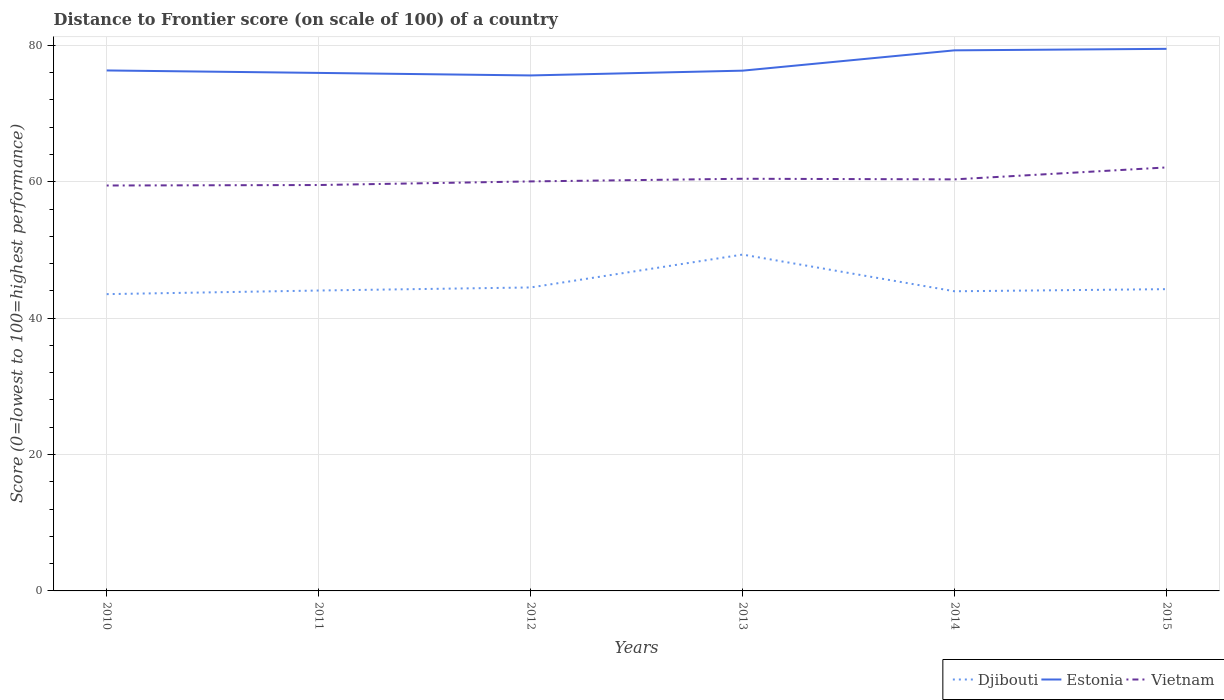How many different coloured lines are there?
Offer a terse response. 3. Is the number of lines equal to the number of legend labels?
Provide a short and direct response. Yes. Across all years, what is the maximum distance to frontier score of in Djibouti?
Your answer should be very brief. 43.52. In which year was the distance to frontier score of in Vietnam maximum?
Your answer should be compact. 2010. What is the difference between the highest and the second highest distance to frontier score of in Djibouti?
Your response must be concise. 5.8. What is the difference between the highest and the lowest distance to frontier score of in Estonia?
Provide a succinct answer. 2. Is the distance to frontier score of in Vietnam strictly greater than the distance to frontier score of in Estonia over the years?
Ensure brevity in your answer.  Yes. How many lines are there?
Make the answer very short. 3. How many years are there in the graph?
Offer a terse response. 6. Are the values on the major ticks of Y-axis written in scientific E-notation?
Provide a short and direct response. No. Where does the legend appear in the graph?
Provide a short and direct response. Bottom right. What is the title of the graph?
Your answer should be very brief. Distance to Frontier score (on scale of 100) of a country. What is the label or title of the Y-axis?
Keep it short and to the point. Score (0=lowest to 100=highest performance). What is the Score (0=lowest to 100=highest performance) of Djibouti in 2010?
Offer a very short reply. 43.52. What is the Score (0=lowest to 100=highest performance) in Estonia in 2010?
Make the answer very short. 76.32. What is the Score (0=lowest to 100=highest performance) of Vietnam in 2010?
Your response must be concise. 59.45. What is the Score (0=lowest to 100=highest performance) in Djibouti in 2011?
Provide a short and direct response. 44.05. What is the Score (0=lowest to 100=highest performance) in Estonia in 2011?
Give a very brief answer. 75.96. What is the Score (0=lowest to 100=highest performance) in Vietnam in 2011?
Give a very brief answer. 59.52. What is the Score (0=lowest to 100=highest performance) of Djibouti in 2012?
Your response must be concise. 44.5. What is the Score (0=lowest to 100=highest performance) in Estonia in 2012?
Offer a terse response. 75.59. What is the Score (0=lowest to 100=highest performance) in Vietnam in 2012?
Your response must be concise. 60.05. What is the Score (0=lowest to 100=highest performance) in Djibouti in 2013?
Give a very brief answer. 49.32. What is the Score (0=lowest to 100=highest performance) of Estonia in 2013?
Provide a short and direct response. 76.29. What is the Score (0=lowest to 100=highest performance) of Vietnam in 2013?
Provide a short and direct response. 60.44. What is the Score (0=lowest to 100=highest performance) of Djibouti in 2014?
Make the answer very short. 43.94. What is the Score (0=lowest to 100=highest performance) of Estonia in 2014?
Offer a terse response. 79.27. What is the Score (0=lowest to 100=highest performance) in Vietnam in 2014?
Your answer should be very brief. 60.35. What is the Score (0=lowest to 100=highest performance) in Djibouti in 2015?
Provide a short and direct response. 44.25. What is the Score (0=lowest to 100=highest performance) of Estonia in 2015?
Make the answer very short. 79.49. What is the Score (0=lowest to 100=highest performance) of Vietnam in 2015?
Offer a very short reply. 62.1. Across all years, what is the maximum Score (0=lowest to 100=highest performance) in Djibouti?
Provide a succinct answer. 49.32. Across all years, what is the maximum Score (0=lowest to 100=highest performance) of Estonia?
Make the answer very short. 79.49. Across all years, what is the maximum Score (0=lowest to 100=highest performance) of Vietnam?
Provide a succinct answer. 62.1. Across all years, what is the minimum Score (0=lowest to 100=highest performance) in Djibouti?
Give a very brief answer. 43.52. Across all years, what is the minimum Score (0=lowest to 100=highest performance) of Estonia?
Provide a succinct answer. 75.59. Across all years, what is the minimum Score (0=lowest to 100=highest performance) in Vietnam?
Ensure brevity in your answer.  59.45. What is the total Score (0=lowest to 100=highest performance) of Djibouti in the graph?
Ensure brevity in your answer.  269.58. What is the total Score (0=lowest to 100=highest performance) of Estonia in the graph?
Your response must be concise. 462.92. What is the total Score (0=lowest to 100=highest performance) of Vietnam in the graph?
Offer a terse response. 361.91. What is the difference between the Score (0=lowest to 100=highest performance) of Djibouti in 2010 and that in 2011?
Your answer should be compact. -0.53. What is the difference between the Score (0=lowest to 100=highest performance) of Estonia in 2010 and that in 2011?
Your response must be concise. 0.36. What is the difference between the Score (0=lowest to 100=highest performance) in Vietnam in 2010 and that in 2011?
Your answer should be compact. -0.07. What is the difference between the Score (0=lowest to 100=highest performance) of Djibouti in 2010 and that in 2012?
Offer a terse response. -0.98. What is the difference between the Score (0=lowest to 100=highest performance) in Estonia in 2010 and that in 2012?
Provide a succinct answer. 0.73. What is the difference between the Score (0=lowest to 100=highest performance) of Djibouti in 2010 and that in 2013?
Keep it short and to the point. -5.8. What is the difference between the Score (0=lowest to 100=highest performance) of Vietnam in 2010 and that in 2013?
Your answer should be very brief. -0.99. What is the difference between the Score (0=lowest to 100=highest performance) in Djibouti in 2010 and that in 2014?
Your answer should be very brief. -0.42. What is the difference between the Score (0=lowest to 100=highest performance) of Estonia in 2010 and that in 2014?
Your response must be concise. -2.95. What is the difference between the Score (0=lowest to 100=highest performance) of Vietnam in 2010 and that in 2014?
Give a very brief answer. -0.9. What is the difference between the Score (0=lowest to 100=highest performance) in Djibouti in 2010 and that in 2015?
Ensure brevity in your answer.  -0.73. What is the difference between the Score (0=lowest to 100=highest performance) of Estonia in 2010 and that in 2015?
Provide a succinct answer. -3.17. What is the difference between the Score (0=lowest to 100=highest performance) of Vietnam in 2010 and that in 2015?
Keep it short and to the point. -2.65. What is the difference between the Score (0=lowest to 100=highest performance) in Djibouti in 2011 and that in 2012?
Keep it short and to the point. -0.45. What is the difference between the Score (0=lowest to 100=highest performance) in Estonia in 2011 and that in 2012?
Keep it short and to the point. 0.37. What is the difference between the Score (0=lowest to 100=highest performance) in Vietnam in 2011 and that in 2012?
Give a very brief answer. -0.53. What is the difference between the Score (0=lowest to 100=highest performance) of Djibouti in 2011 and that in 2013?
Your response must be concise. -5.27. What is the difference between the Score (0=lowest to 100=highest performance) of Estonia in 2011 and that in 2013?
Your answer should be compact. -0.33. What is the difference between the Score (0=lowest to 100=highest performance) of Vietnam in 2011 and that in 2013?
Provide a short and direct response. -0.92. What is the difference between the Score (0=lowest to 100=highest performance) of Djibouti in 2011 and that in 2014?
Keep it short and to the point. 0.11. What is the difference between the Score (0=lowest to 100=highest performance) in Estonia in 2011 and that in 2014?
Your answer should be compact. -3.31. What is the difference between the Score (0=lowest to 100=highest performance) in Vietnam in 2011 and that in 2014?
Give a very brief answer. -0.83. What is the difference between the Score (0=lowest to 100=highest performance) of Estonia in 2011 and that in 2015?
Provide a succinct answer. -3.53. What is the difference between the Score (0=lowest to 100=highest performance) in Vietnam in 2011 and that in 2015?
Give a very brief answer. -2.58. What is the difference between the Score (0=lowest to 100=highest performance) of Djibouti in 2012 and that in 2013?
Keep it short and to the point. -4.82. What is the difference between the Score (0=lowest to 100=highest performance) of Vietnam in 2012 and that in 2013?
Give a very brief answer. -0.39. What is the difference between the Score (0=lowest to 100=highest performance) in Djibouti in 2012 and that in 2014?
Give a very brief answer. 0.56. What is the difference between the Score (0=lowest to 100=highest performance) in Estonia in 2012 and that in 2014?
Ensure brevity in your answer.  -3.68. What is the difference between the Score (0=lowest to 100=highest performance) in Vietnam in 2012 and that in 2015?
Give a very brief answer. -2.05. What is the difference between the Score (0=lowest to 100=highest performance) of Djibouti in 2013 and that in 2014?
Give a very brief answer. 5.38. What is the difference between the Score (0=lowest to 100=highest performance) in Estonia in 2013 and that in 2014?
Your answer should be compact. -2.98. What is the difference between the Score (0=lowest to 100=highest performance) of Vietnam in 2013 and that in 2014?
Keep it short and to the point. 0.09. What is the difference between the Score (0=lowest to 100=highest performance) in Djibouti in 2013 and that in 2015?
Your answer should be compact. 5.07. What is the difference between the Score (0=lowest to 100=highest performance) of Vietnam in 2013 and that in 2015?
Your answer should be compact. -1.66. What is the difference between the Score (0=lowest to 100=highest performance) of Djibouti in 2014 and that in 2015?
Your answer should be very brief. -0.31. What is the difference between the Score (0=lowest to 100=highest performance) of Estonia in 2014 and that in 2015?
Give a very brief answer. -0.22. What is the difference between the Score (0=lowest to 100=highest performance) of Vietnam in 2014 and that in 2015?
Offer a terse response. -1.75. What is the difference between the Score (0=lowest to 100=highest performance) of Djibouti in 2010 and the Score (0=lowest to 100=highest performance) of Estonia in 2011?
Your answer should be compact. -32.44. What is the difference between the Score (0=lowest to 100=highest performance) of Djibouti in 2010 and the Score (0=lowest to 100=highest performance) of Vietnam in 2011?
Your response must be concise. -16. What is the difference between the Score (0=lowest to 100=highest performance) in Djibouti in 2010 and the Score (0=lowest to 100=highest performance) in Estonia in 2012?
Provide a short and direct response. -32.07. What is the difference between the Score (0=lowest to 100=highest performance) of Djibouti in 2010 and the Score (0=lowest to 100=highest performance) of Vietnam in 2012?
Provide a short and direct response. -16.53. What is the difference between the Score (0=lowest to 100=highest performance) in Estonia in 2010 and the Score (0=lowest to 100=highest performance) in Vietnam in 2012?
Ensure brevity in your answer.  16.27. What is the difference between the Score (0=lowest to 100=highest performance) of Djibouti in 2010 and the Score (0=lowest to 100=highest performance) of Estonia in 2013?
Your answer should be compact. -32.77. What is the difference between the Score (0=lowest to 100=highest performance) of Djibouti in 2010 and the Score (0=lowest to 100=highest performance) of Vietnam in 2013?
Your answer should be compact. -16.92. What is the difference between the Score (0=lowest to 100=highest performance) in Estonia in 2010 and the Score (0=lowest to 100=highest performance) in Vietnam in 2013?
Keep it short and to the point. 15.88. What is the difference between the Score (0=lowest to 100=highest performance) of Djibouti in 2010 and the Score (0=lowest to 100=highest performance) of Estonia in 2014?
Offer a terse response. -35.75. What is the difference between the Score (0=lowest to 100=highest performance) of Djibouti in 2010 and the Score (0=lowest to 100=highest performance) of Vietnam in 2014?
Make the answer very short. -16.83. What is the difference between the Score (0=lowest to 100=highest performance) of Estonia in 2010 and the Score (0=lowest to 100=highest performance) of Vietnam in 2014?
Offer a terse response. 15.97. What is the difference between the Score (0=lowest to 100=highest performance) in Djibouti in 2010 and the Score (0=lowest to 100=highest performance) in Estonia in 2015?
Give a very brief answer. -35.97. What is the difference between the Score (0=lowest to 100=highest performance) in Djibouti in 2010 and the Score (0=lowest to 100=highest performance) in Vietnam in 2015?
Your answer should be very brief. -18.58. What is the difference between the Score (0=lowest to 100=highest performance) in Estonia in 2010 and the Score (0=lowest to 100=highest performance) in Vietnam in 2015?
Provide a succinct answer. 14.22. What is the difference between the Score (0=lowest to 100=highest performance) in Djibouti in 2011 and the Score (0=lowest to 100=highest performance) in Estonia in 2012?
Make the answer very short. -31.54. What is the difference between the Score (0=lowest to 100=highest performance) of Estonia in 2011 and the Score (0=lowest to 100=highest performance) of Vietnam in 2012?
Make the answer very short. 15.91. What is the difference between the Score (0=lowest to 100=highest performance) in Djibouti in 2011 and the Score (0=lowest to 100=highest performance) in Estonia in 2013?
Your response must be concise. -32.24. What is the difference between the Score (0=lowest to 100=highest performance) in Djibouti in 2011 and the Score (0=lowest to 100=highest performance) in Vietnam in 2013?
Make the answer very short. -16.39. What is the difference between the Score (0=lowest to 100=highest performance) in Estonia in 2011 and the Score (0=lowest to 100=highest performance) in Vietnam in 2013?
Offer a terse response. 15.52. What is the difference between the Score (0=lowest to 100=highest performance) in Djibouti in 2011 and the Score (0=lowest to 100=highest performance) in Estonia in 2014?
Provide a succinct answer. -35.22. What is the difference between the Score (0=lowest to 100=highest performance) of Djibouti in 2011 and the Score (0=lowest to 100=highest performance) of Vietnam in 2014?
Offer a very short reply. -16.3. What is the difference between the Score (0=lowest to 100=highest performance) of Estonia in 2011 and the Score (0=lowest to 100=highest performance) of Vietnam in 2014?
Your response must be concise. 15.61. What is the difference between the Score (0=lowest to 100=highest performance) in Djibouti in 2011 and the Score (0=lowest to 100=highest performance) in Estonia in 2015?
Make the answer very short. -35.44. What is the difference between the Score (0=lowest to 100=highest performance) of Djibouti in 2011 and the Score (0=lowest to 100=highest performance) of Vietnam in 2015?
Provide a succinct answer. -18.05. What is the difference between the Score (0=lowest to 100=highest performance) in Estonia in 2011 and the Score (0=lowest to 100=highest performance) in Vietnam in 2015?
Make the answer very short. 13.86. What is the difference between the Score (0=lowest to 100=highest performance) of Djibouti in 2012 and the Score (0=lowest to 100=highest performance) of Estonia in 2013?
Make the answer very short. -31.79. What is the difference between the Score (0=lowest to 100=highest performance) of Djibouti in 2012 and the Score (0=lowest to 100=highest performance) of Vietnam in 2013?
Your answer should be compact. -15.94. What is the difference between the Score (0=lowest to 100=highest performance) in Estonia in 2012 and the Score (0=lowest to 100=highest performance) in Vietnam in 2013?
Your answer should be compact. 15.15. What is the difference between the Score (0=lowest to 100=highest performance) in Djibouti in 2012 and the Score (0=lowest to 100=highest performance) in Estonia in 2014?
Offer a very short reply. -34.77. What is the difference between the Score (0=lowest to 100=highest performance) of Djibouti in 2012 and the Score (0=lowest to 100=highest performance) of Vietnam in 2014?
Offer a terse response. -15.85. What is the difference between the Score (0=lowest to 100=highest performance) in Estonia in 2012 and the Score (0=lowest to 100=highest performance) in Vietnam in 2014?
Provide a succinct answer. 15.24. What is the difference between the Score (0=lowest to 100=highest performance) of Djibouti in 2012 and the Score (0=lowest to 100=highest performance) of Estonia in 2015?
Offer a very short reply. -34.99. What is the difference between the Score (0=lowest to 100=highest performance) of Djibouti in 2012 and the Score (0=lowest to 100=highest performance) of Vietnam in 2015?
Offer a very short reply. -17.6. What is the difference between the Score (0=lowest to 100=highest performance) in Estonia in 2012 and the Score (0=lowest to 100=highest performance) in Vietnam in 2015?
Make the answer very short. 13.49. What is the difference between the Score (0=lowest to 100=highest performance) in Djibouti in 2013 and the Score (0=lowest to 100=highest performance) in Estonia in 2014?
Offer a very short reply. -29.95. What is the difference between the Score (0=lowest to 100=highest performance) in Djibouti in 2013 and the Score (0=lowest to 100=highest performance) in Vietnam in 2014?
Offer a terse response. -11.03. What is the difference between the Score (0=lowest to 100=highest performance) of Estonia in 2013 and the Score (0=lowest to 100=highest performance) of Vietnam in 2014?
Keep it short and to the point. 15.94. What is the difference between the Score (0=lowest to 100=highest performance) of Djibouti in 2013 and the Score (0=lowest to 100=highest performance) of Estonia in 2015?
Give a very brief answer. -30.17. What is the difference between the Score (0=lowest to 100=highest performance) of Djibouti in 2013 and the Score (0=lowest to 100=highest performance) of Vietnam in 2015?
Ensure brevity in your answer.  -12.78. What is the difference between the Score (0=lowest to 100=highest performance) in Estonia in 2013 and the Score (0=lowest to 100=highest performance) in Vietnam in 2015?
Give a very brief answer. 14.19. What is the difference between the Score (0=lowest to 100=highest performance) in Djibouti in 2014 and the Score (0=lowest to 100=highest performance) in Estonia in 2015?
Offer a very short reply. -35.55. What is the difference between the Score (0=lowest to 100=highest performance) of Djibouti in 2014 and the Score (0=lowest to 100=highest performance) of Vietnam in 2015?
Your answer should be very brief. -18.16. What is the difference between the Score (0=lowest to 100=highest performance) in Estonia in 2014 and the Score (0=lowest to 100=highest performance) in Vietnam in 2015?
Make the answer very short. 17.17. What is the average Score (0=lowest to 100=highest performance) in Djibouti per year?
Your answer should be very brief. 44.93. What is the average Score (0=lowest to 100=highest performance) in Estonia per year?
Give a very brief answer. 77.15. What is the average Score (0=lowest to 100=highest performance) of Vietnam per year?
Your answer should be compact. 60.32. In the year 2010, what is the difference between the Score (0=lowest to 100=highest performance) of Djibouti and Score (0=lowest to 100=highest performance) of Estonia?
Make the answer very short. -32.8. In the year 2010, what is the difference between the Score (0=lowest to 100=highest performance) in Djibouti and Score (0=lowest to 100=highest performance) in Vietnam?
Your answer should be very brief. -15.93. In the year 2010, what is the difference between the Score (0=lowest to 100=highest performance) in Estonia and Score (0=lowest to 100=highest performance) in Vietnam?
Offer a very short reply. 16.87. In the year 2011, what is the difference between the Score (0=lowest to 100=highest performance) in Djibouti and Score (0=lowest to 100=highest performance) in Estonia?
Offer a very short reply. -31.91. In the year 2011, what is the difference between the Score (0=lowest to 100=highest performance) of Djibouti and Score (0=lowest to 100=highest performance) of Vietnam?
Offer a very short reply. -15.47. In the year 2011, what is the difference between the Score (0=lowest to 100=highest performance) of Estonia and Score (0=lowest to 100=highest performance) of Vietnam?
Give a very brief answer. 16.44. In the year 2012, what is the difference between the Score (0=lowest to 100=highest performance) of Djibouti and Score (0=lowest to 100=highest performance) of Estonia?
Provide a short and direct response. -31.09. In the year 2012, what is the difference between the Score (0=lowest to 100=highest performance) in Djibouti and Score (0=lowest to 100=highest performance) in Vietnam?
Give a very brief answer. -15.55. In the year 2012, what is the difference between the Score (0=lowest to 100=highest performance) in Estonia and Score (0=lowest to 100=highest performance) in Vietnam?
Provide a succinct answer. 15.54. In the year 2013, what is the difference between the Score (0=lowest to 100=highest performance) of Djibouti and Score (0=lowest to 100=highest performance) of Estonia?
Your answer should be very brief. -26.97. In the year 2013, what is the difference between the Score (0=lowest to 100=highest performance) in Djibouti and Score (0=lowest to 100=highest performance) in Vietnam?
Provide a short and direct response. -11.12. In the year 2013, what is the difference between the Score (0=lowest to 100=highest performance) of Estonia and Score (0=lowest to 100=highest performance) of Vietnam?
Keep it short and to the point. 15.85. In the year 2014, what is the difference between the Score (0=lowest to 100=highest performance) in Djibouti and Score (0=lowest to 100=highest performance) in Estonia?
Your answer should be compact. -35.33. In the year 2014, what is the difference between the Score (0=lowest to 100=highest performance) in Djibouti and Score (0=lowest to 100=highest performance) in Vietnam?
Provide a short and direct response. -16.41. In the year 2014, what is the difference between the Score (0=lowest to 100=highest performance) in Estonia and Score (0=lowest to 100=highest performance) in Vietnam?
Keep it short and to the point. 18.92. In the year 2015, what is the difference between the Score (0=lowest to 100=highest performance) of Djibouti and Score (0=lowest to 100=highest performance) of Estonia?
Give a very brief answer. -35.24. In the year 2015, what is the difference between the Score (0=lowest to 100=highest performance) in Djibouti and Score (0=lowest to 100=highest performance) in Vietnam?
Offer a very short reply. -17.85. In the year 2015, what is the difference between the Score (0=lowest to 100=highest performance) in Estonia and Score (0=lowest to 100=highest performance) in Vietnam?
Ensure brevity in your answer.  17.39. What is the ratio of the Score (0=lowest to 100=highest performance) in Djibouti in 2010 to that in 2011?
Your answer should be compact. 0.99. What is the ratio of the Score (0=lowest to 100=highest performance) of Estonia in 2010 to that in 2011?
Your answer should be compact. 1. What is the ratio of the Score (0=lowest to 100=highest performance) of Djibouti in 2010 to that in 2012?
Offer a terse response. 0.98. What is the ratio of the Score (0=lowest to 100=highest performance) in Estonia in 2010 to that in 2012?
Provide a short and direct response. 1.01. What is the ratio of the Score (0=lowest to 100=highest performance) of Vietnam in 2010 to that in 2012?
Give a very brief answer. 0.99. What is the ratio of the Score (0=lowest to 100=highest performance) of Djibouti in 2010 to that in 2013?
Your answer should be very brief. 0.88. What is the ratio of the Score (0=lowest to 100=highest performance) of Estonia in 2010 to that in 2013?
Your answer should be very brief. 1. What is the ratio of the Score (0=lowest to 100=highest performance) in Vietnam in 2010 to that in 2013?
Offer a very short reply. 0.98. What is the ratio of the Score (0=lowest to 100=highest performance) of Djibouti in 2010 to that in 2014?
Ensure brevity in your answer.  0.99. What is the ratio of the Score (0=lowest to 100=highest performance) of Estonia in 2010 to that in 2014?
Your answer should be very brief. 0.96. What is the ratio of the Score (0=lowest to 100=highest performance) of Vietnam in 2010 to that in 2014?
Your answer should be compact. 0.99. What is the ratio of the Score (0=lowest to 100=highest performance) of Djibouti in 2010 to that in 2015?
Provide a short and direct response. 0.98. What is the ratio of the Score (0=lowest to 100=highest performance) of Estonia in 2010 to that in 2015?
Make the answer very short. 0.96. What is the ratio of the Score (0=lowest to 100=highest performance) in Vietnam in 2010 to that in 2015?
Make the answer very short. 0.96. What is the ratio of the Score (0=lowest to 100=highest performance) of Djibouti in 2011 to that in 2012?
Offer a terse response. 0.99. What is the ratio of the Score (0=lowest to 100=highest performance) in Estonia in 2011 to that in 2012?
Keep it short and to the point. 1. What is the ratio of the Score (0=lowest to 100=highest performance) of Djibouti in 2011 to that in 2013?
Keep it short and to the point. 0.89. What is the ratio of the Score (0=lowest to 100=highest performance) of Vietnam in 2011 to that in 2013?
Give a very brief answer. 0.98. What is the ratio of the Score (0=lowest to 100=highest performance) in Djibouti in 2011 to that in 2014?
Ensure brevity in your answer.  1. What is the ratio of the Score (0=lowest to 100=highest performance) in Estonia in 2011 to that in 2014?
Your response must be concise. 0.96. What is the ratio of the Score (0=lowest to 100=highest performance) of Vietnam in 2011 to that in 2014?
Provide a succinct answer. 0.99. What is the ratio of the Score (0=lowest to 100=highest performance) in Djibouti in 2011 to that in 2015?
Provide a short and direct response. 1. What is the ratio of the Score (0=lowest to 100=highest performance) in Estonia in 2011 to that in 2015?
Your answer should be compact. 0.96. What is the ratio of the Score (0=lowest to 100=highest performance) in Vietnam in 2011 to that in 2015?
Provide a succinct answer. 0.96. What is the ratio of the Score (0=lowest to 100=highest performance) of Djibouti in 2012 to that in 2013?
Ensure brevity in your answer.  0.9. What is the ratio of the Score (0=lowest to 100=highest performance) in Vietnam in 2012 to that in 2013?
Ensure brevity in your answer.  0.99. What is the ratio of the Score (0=lowest to 100=highest performance) of Djibouti in 2012 to that in 2014?
Provide a succinct answer. 1.01. What is the ratio of the Score (0=lowest to 100=highest performance) in Estonia in 2012 to that in 2014?
Offer a very short reply. 0.95. What is the ratio of the Score (0=lowest to 100=highest performance) in Vietnam in 2012 to that in 2014?
Offer a very short reply. 0.99. What is the ratio of the Score (0=lowest to 100=highest performance) of Djibouti in 2012 to that in 2015?
Give a very brief answer. 1.01. What is the ratio of the Score (0=lowest to 100=highest performance) in Estonia in 2012 to that in 2015?
Keep it short and to the point. 0.95. What is the ratio of the Score (0=lowest to 100=highest performance) in Djibouti in 2013 to that in 2014?
Provide a short and direct response. 1.12. What is the ratio of the Score (0=lowest to 100=highest performance) of Estonia in 2013 to that in 2014?
Offer a very short reply. 0.96. What is the ratio of the Score (0=lowest to 100=highest performance) in Djibouti in 2013 to that in 2015?
Keep it short and to the point. 1.11. What is the ratio of the Score (0=lowest to 100=highest performance) in Estonia in 2013 to that in 2015?
Your answer should be very brief. 0.96. What is the ratio of the Score (0=lowest to 100=highest performance) in Vietnam in 2013 to that in 2015?
Your response must be concise. 0.97. What is the ratio of the Score (0=lowest to 100=highest performance) of Estonia in 2014 to that in 2015?
Ensure brevity in your answer.  1. What is the ratio of the Score (0=lowest to 100=highest performance) in Vietnam in 2014 to that in 2015?
Make the answer very short. 0.97. What is the difference between the highest and the second highest Score (0=lowest to 100=highest performance) of Djibouti?
Your answer should be very brief. 4.82. What is the difference between the highest and the second highest Score (0=lowest to 100=highest performance) of Estonia?
Ensure brevity in your answer.  0.22. What is the difference between the highest and the second highest Score (0=lowest to 100=highest performance) of Vietnam?
Make the answer very short. 1.66. What is the difference between the highest and the lowest Score (0=lowest to 100=highest performance) of Djibouti?
Your answer should be very brief. 5.8. What is the difference between the highest and the lowest Score (0=lowest to 100=highest performance) in Vietnam?
Offer a very short reply. 2.65. 